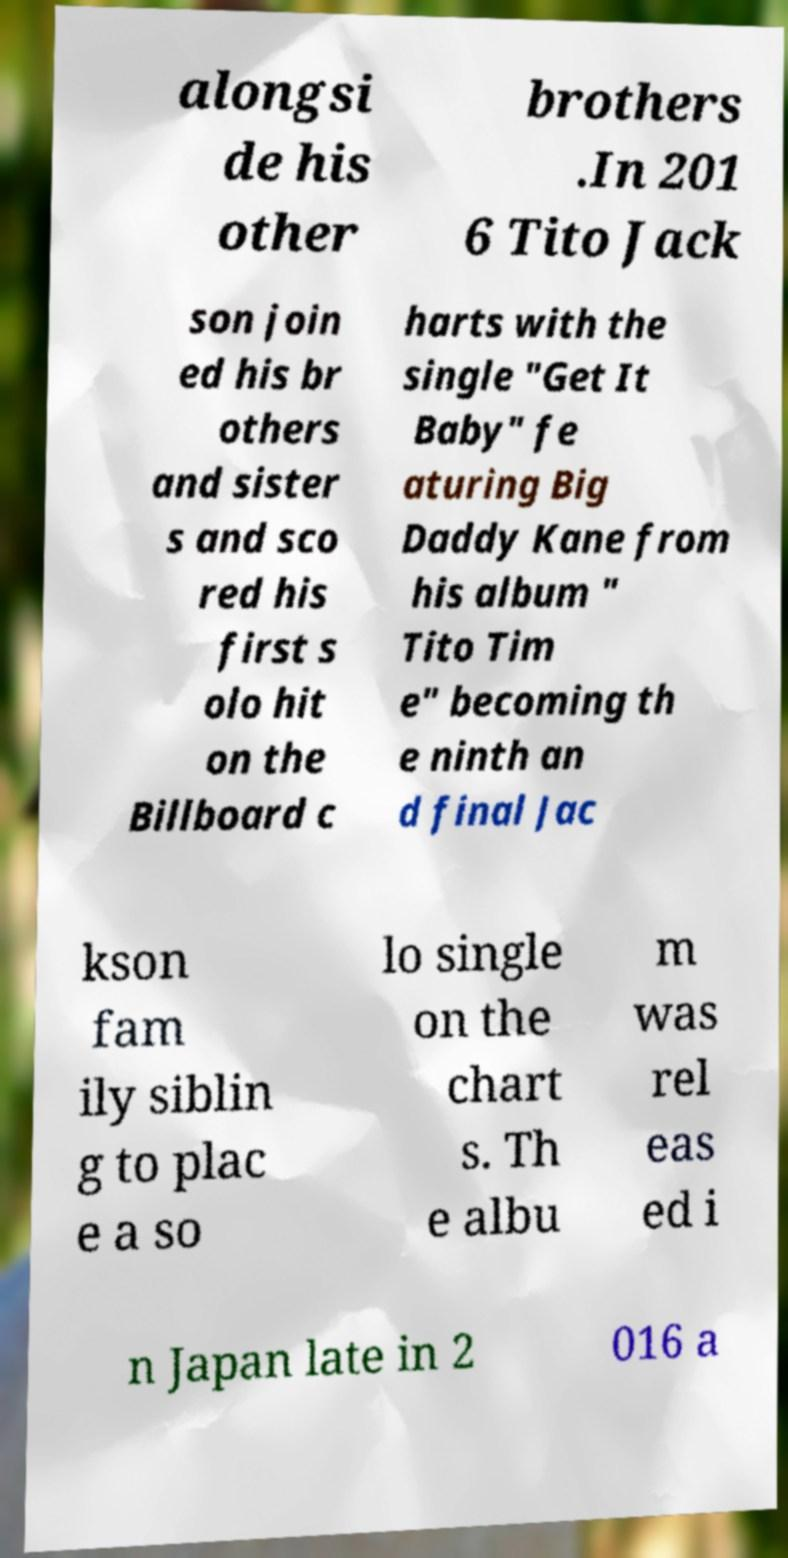There's text embedded in this image that I need extracted. Can you transcribe it verbatim? alongsi de his other brothers .In 201 6 Tito Jack son join ed his br others and sister s and sco red his first s olo hit on the Billboard c harts with the single "Get It Baby" fe aturing Big Daddy Kane from his album " Tito Tim e" becoming th e ninth an d final Jac kson fam ily siblin g to plac e a so lo single on the chart s. Th e albu m was rel eas ed i n Japan late in 2 016 a 